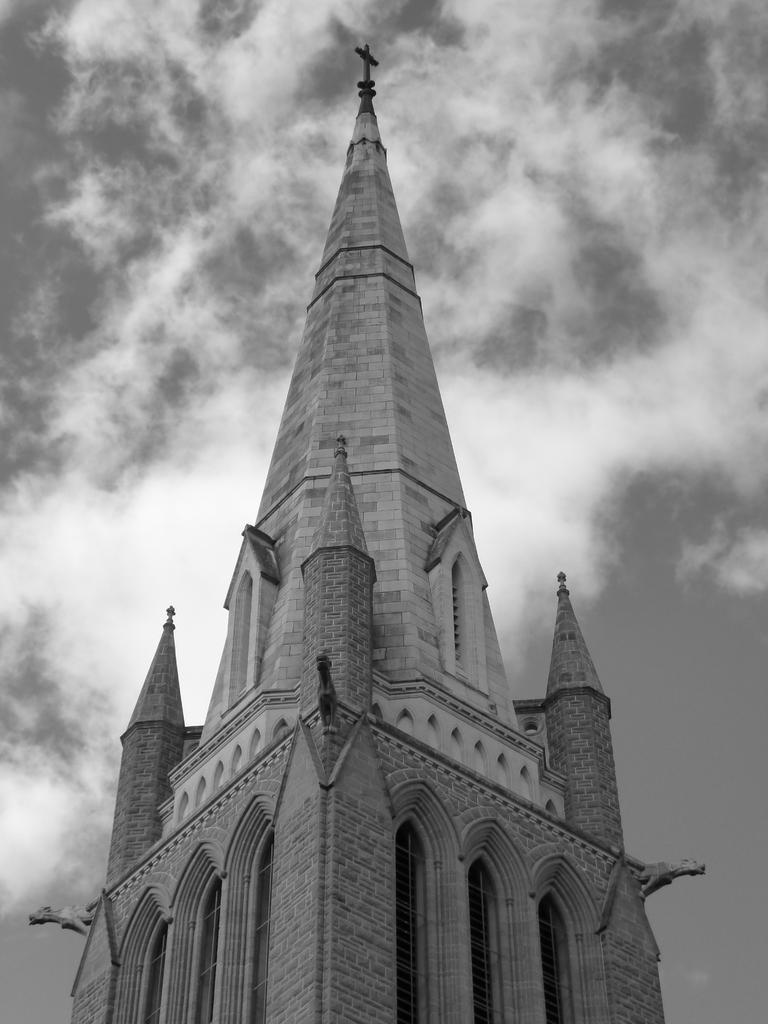Describe this image in one or two sentences. This is a black and white image. In this image we can see a building with a cross. On the backside we can see the sky which looks cloudy. 